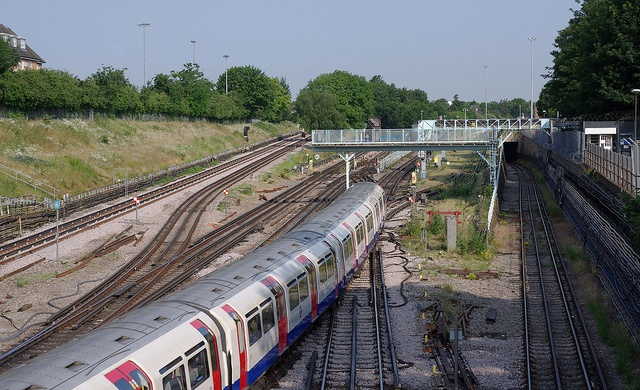Describe the objects in this image and their specific colors. I can see a train in darkgray, gray, and lightgray tones in this image. 